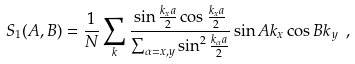<formula> <loc_0><loc_0><loc_500><loc_500>S _ { 1 } ( A , B ) = \frac { 1 } { N } \sum _ { k } \frac { \sin \frac { k _ { x } a } { 2 } \cos \frac { k _ { x } a } { 2 } } { \sum _ { \alpha = x , y } \sin ^ { 2 } \frac { k _ { \alpha } a } { 2 } } \sin A k _ { x } \cos B k _ { y } \ ,</formula> 